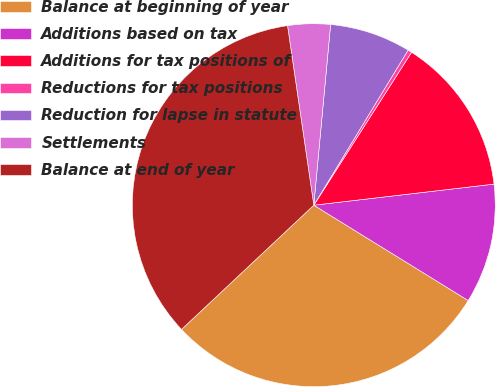<chart> <loc_0><loc_0><loc_500><loc_500><pie_chart><fcel>Balance at beginning of year<fcel>Additions based on tax<fcel>Additions for tax positions of<fcel>Reductions for tax positions<fcel>Reduction for lapse in statute<fcel>Settlements<fcel>Balance at end of year<nl><fcel>29.2%<fcel>10.66%<fcel>14.09%<fcel>0.36%<fcel>7.22%<fcel>3.79%<fcel>34.69%<nl></chart> 